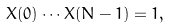<formula> <loc_0><loc_0><loc_500><loc_500>X ( 0 ) \cdots X ( N - 1 ) = 1 ,</formula> 